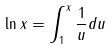<formula> <loc_0><loc_0><loc_500><loc_500>\ln x = \int _ { 1 } ^ { x } \frac { 1 } { u } d u</formula> 